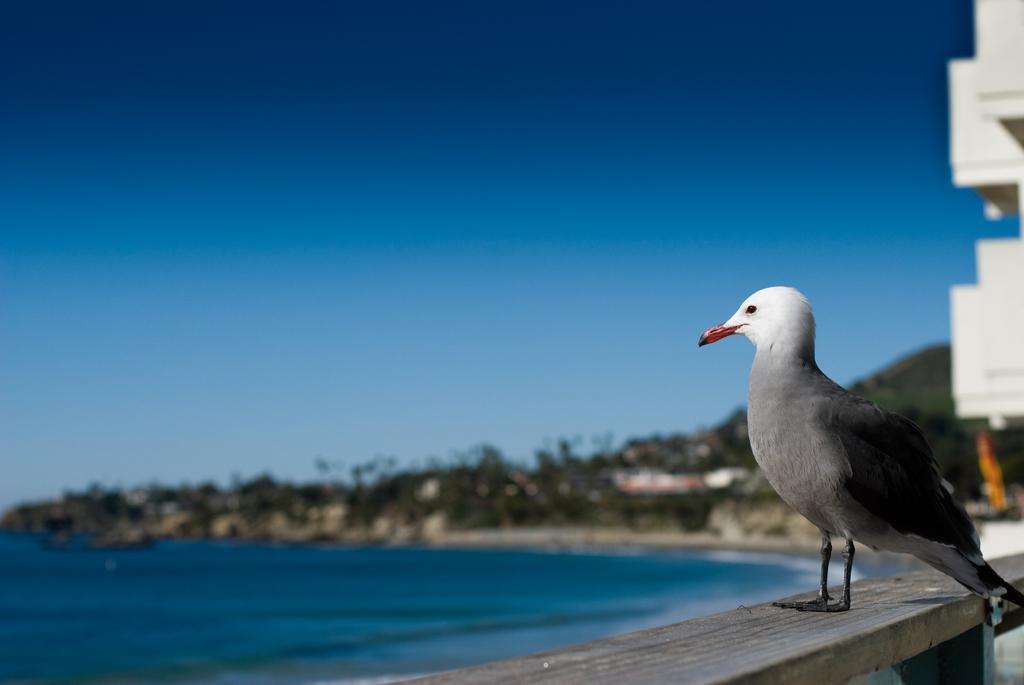Can you describe this image briefly? In this picture I can see there is a bird sitting on the wall and there is a building here on the right. On to left there is a ocean and there is a mountain, trees and the sky is clear. 